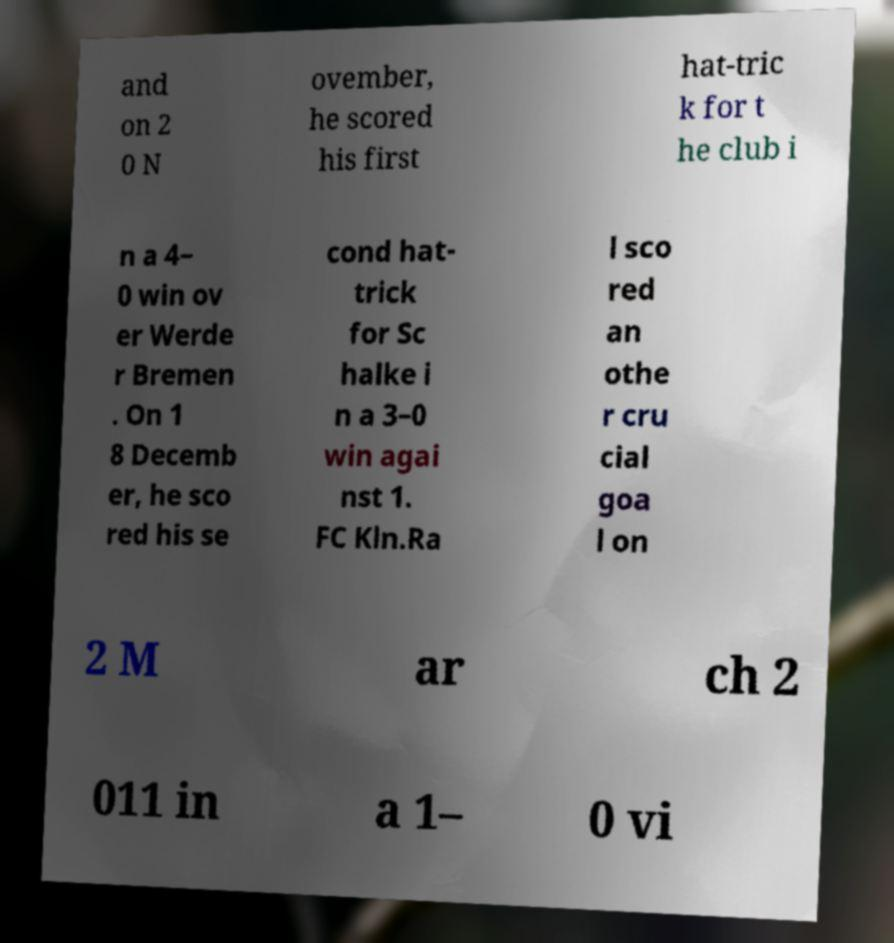Could you extract and type out the text from this image? and on 2 0 N ovember, he scored his first hat-tric k for t he club i n a 4– 0 win ov er Werde r Bremen . On 1 8 Decemb er, he sco red his se cond hat- trick for Sc halke i n a 3–0 win agai nst 1. FC Kln.Ra l sco red an othe r cru cial goa l on 2 M ar ch 2 011 in a 1– 0 vi 